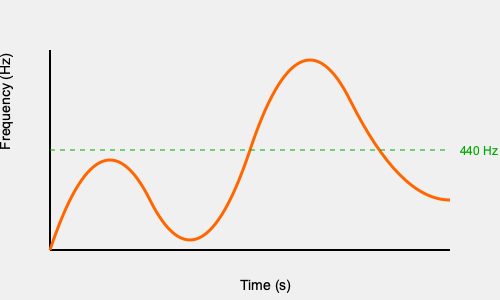Analyze the spectrogram of a classic rockabilly guitar riff shown above. The green dashed line represents the frequency of 440 Hz (A4 note). What musical technique is likely being employed in the section where the frequency rises sharply above 440 Hz and then quickly descends? To answer this question, we need to analyze the spectrogram and understand common rockabilly guitar techniques:

1. The spectrogram shows frequency over time, with higher frequencies at the top and lower frequencies at the bottom.

2. The orange line represents the dominant frequency of the guitar riff over time.

3. We can see that the line starts around 440 Hz (the green dashed line), which is likely the open A string or an A note being played.

4. At approximately the midpoint of the graph, we see a sharp rise in frequency that quickly descends back to a lower frequency.

5. This rapid increase and decrease in frequency is characteristic of a guitar bend technique, where the player pushes the string upward or pulls it downward to raise the pitch, then releases it.

6. In rockabilly music, guitar bends are a common technique used to add expression and a "twangy" sound to the music.

7. The speed and shape of this particular bend (sharp rise and quick release) is typical of the aggressive playing style often found in rockabilly music from the 1980s revival era.

Given this analysis, the most likely technique being employed in this section of the riff is a guitar bend.
Answer: Guitar bend 